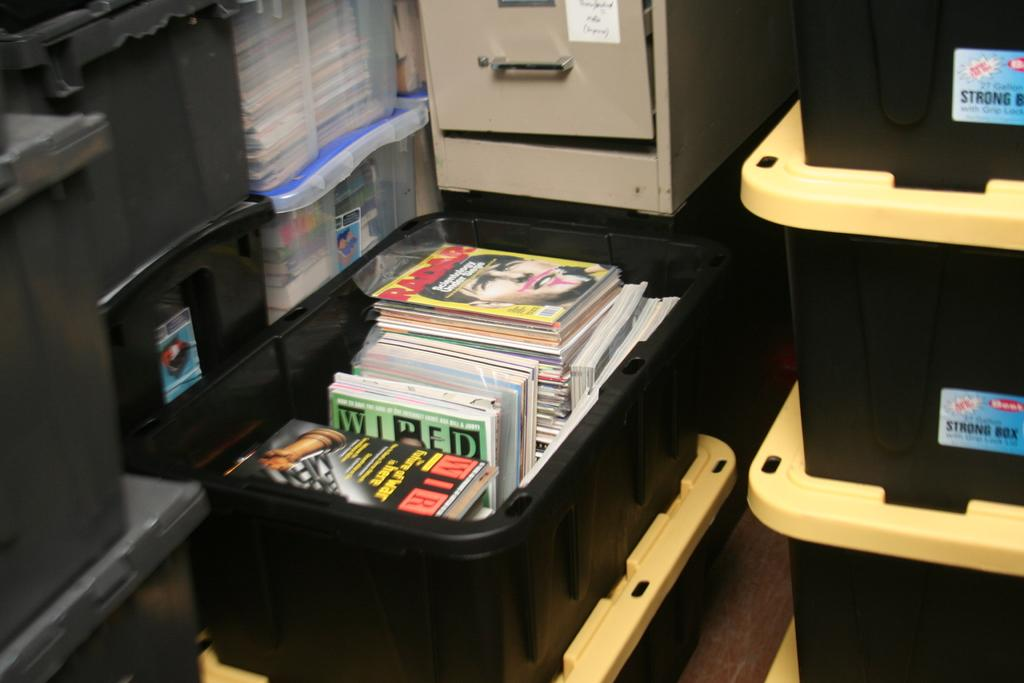<image>
Render a clear and concise summary of the photo. A yellow Radar magazine in a black plastic box. 